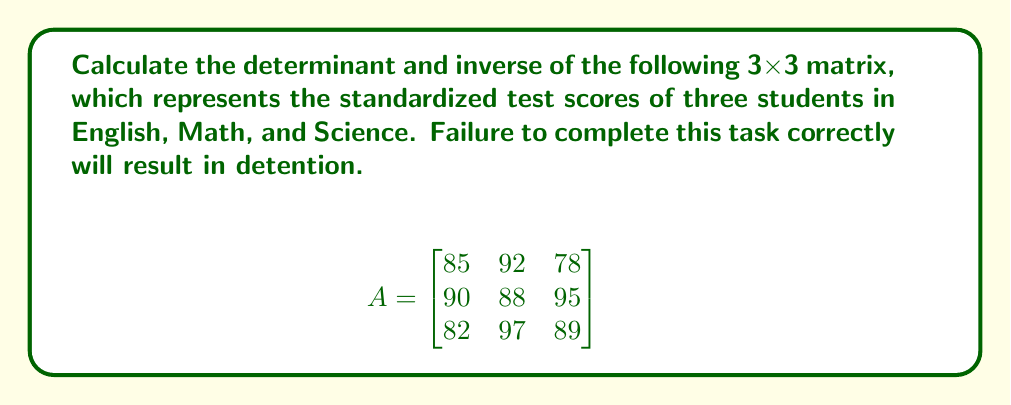Give your solution to this math problem. Step 1: Calculate the determinant using the Sarrus' rule or cofactor expansion.

Using cofactor expansion along the first row:

$\det(A) = 85(88 \cdot 89 - 95 \cdot 97) - 92(90 \cdot 89 - 95 \cdot 82) + 78(90 \cdot 97 - 88 \cdot 82)$

$\det(A) = 85(-1067) - 92(1010) + 78(2938)$
$\det(A) = -90695 - 92920 + 229164$
$\det(A) = 45549$

Step 2: Calculate the adjugate matrix (transpose of cofactor matrix).

$\text{adj}(A) = \begin{bmatrix}
88 \cdot 89 - 95 \cdot 97 & -(90 \cdot 89 - 95 \cdot 82) & 90 \cdot 97 - 88 \cdot 82 \\
-(82 \cdot 89 - 78 \cdot 97) & 85 \cdot 89 - 78 \cdot 82 & -(85 \cdot 97 - 92 \cdot 82) \\
82 \cdot 95 - 78 \cdot 90 & -(85 \cdot 95 - 92 \cdot 90) & 85 \cdot 88 - 92 \cdot 90
\end{bmatrix}$

$\text{adj}(A) = \begin{bmatrix}
-1067 & -1010 & 2938 \\
1054 & 4931 & -2789 \\
1910 & -1105 & -2380
\end{bmatrix}$

Step 3: Calculate the inverse using the formula $A^{-1} = \frac{1}{\det(A)} \cdot \text{adj}(A)$

$A^{-1} = \frac{1}{45549} \cdot \begin{bmatrix}
-1067 & -1010 & 2938 \\
1054 & 4931 & -2789 \\
1910 & -1105 & -2380
\end{bmatrix}$
Answer: $\det(A) = 45549$

$A^{-1} = \begin{bmatrix}
-0.0234 & -0.0222 & 0.0645 \\
0.0231 & 0.1083 & -0.0612 \\
0.0419 & -0.0243 & -0.0523
\end{bmatrix}$ 